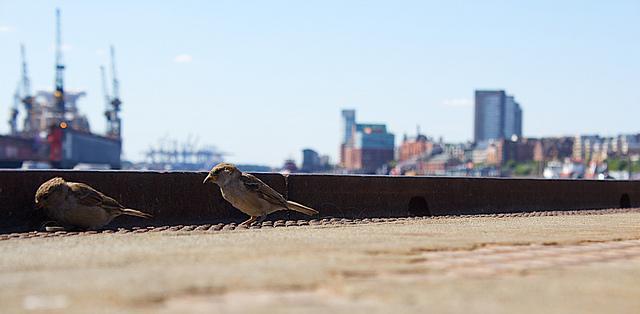How many birds are in the picture?
Give a very brief answer. 2. How many birds are visible?
Give a very brief answer. 2. 